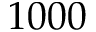<formula> <loc_0><loc_0><loc_500><loc_500>1 0 0 0</formula> 